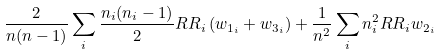<formula> <loc_0><loc_0><loc_500><loc_500>\frac { 2 } { n ( n - 1 ) } \sum _ { i } \frac { n _ { i } ( n _ { i } - 1 ) } { 2 } R R _ { i } \left ( w _ { 1 _ { i } } + w _ { 3 _ { i } } \right ) + \frac { 1 } { n ^ { 2 } } \sum _ { i } n _ { i } ^ { 2 } R R _ { i } w _ { 2 _ { i } }</formula> 